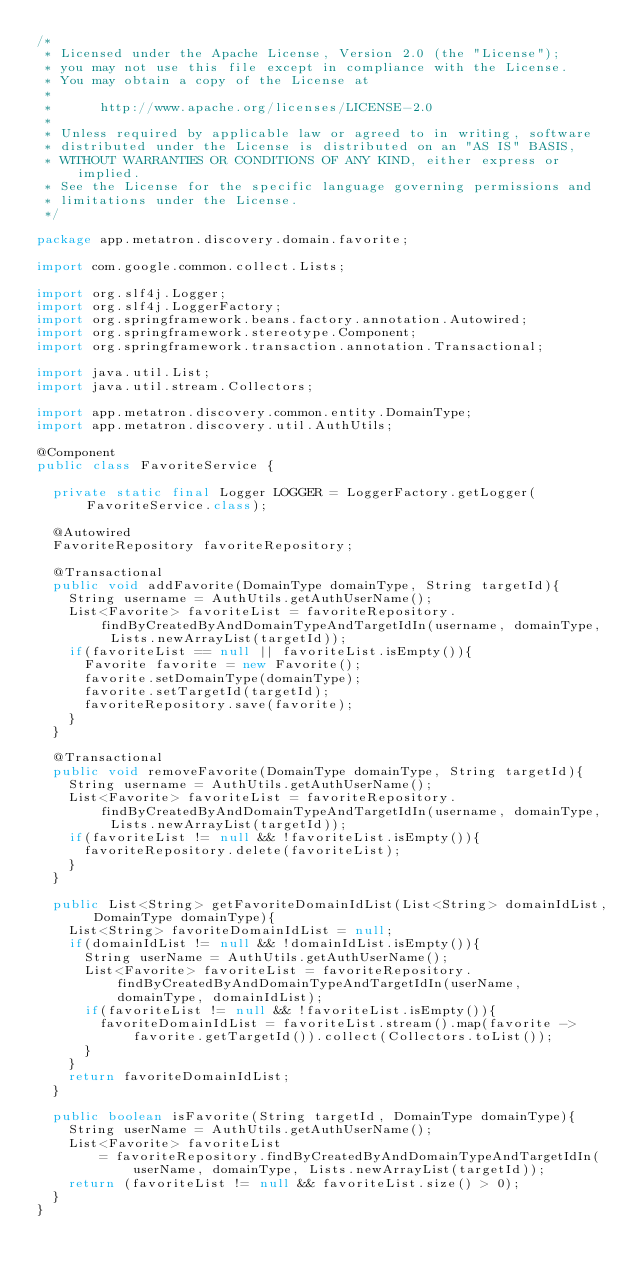<code> <loc_0><loc_0><loc_500><loc_500><_Java_>/*
 * Licensed under the Apache License, Version 2.0 (the "License");
 * you may not use this file except in compliance with the License.
 * You may obtain a copy of the License at
 *
 *      http://www.apache.org/licenses/LICENSE-2.0
 *
 * Unless required by applicable law or agreed to in writing, software
 * distributed under the License is distributed on an "AS IS" BASIS,
 * WITHOUT WARRANTIES OR CONDITIONS OF ANY KIND, either express or implied.
 * See the License for the specific language governing permissions and
 * limitations under the License.
 */

package app.metatron.discovery.domain.favorite;

import com.google.common.collect.Lists;

import org.slf4j.Logger;
import org.slf4j.LoggerFactory;
import org.springframework.beans.factory.annotation.Autowired;
import org.springframework.stereotype.Component;
import org.springframework.transaction.annotation.Transactional;

import java.util.List;
import java.util.stream.Collectors;

import app.metatron.discovery.common.entity.DomainType;
import app.metatron.discovery.util.AuthUtils;

@Component
public class FavoriteService {

  private static final Logger LOGGER = LoggerFactory.getLogger(FavoriteService.class);

  @Autowired
  FavoriteRepository favoriteRepository;

  @Transactional
  public void addFavorite(DomainType domainType, String targetId){
    String username = AuthUtils.getAuthUserName();
    List<Favorite> favoriteList = favoriteRepository.findByCreatedByAndDomainTypeAndTargetIdIn(username, domainType, Lists.newArrayList(targetId));
    if(favoriteList == null || favoriteList.isEmpty()){
      Favorite favorite = new Favorite();
      favorite.setDomainType(domainType);
      favorite.setTargetId(targetId);
      favoriteRepository.save(favorite);
    }
  }

  @Transactional
  public void removeFavorite(DomainType domainType, String targetId){
    String username = AuthUtils.getAuthUserName();
    List<Favorite> favoriteList = favoriteRepository.findByCreatedByAndDomainTypeAndTargetIdIn(username, domainType, Lists.newArrayList(targetId));
    if(favoriteList != null && !favoriteList.isEmpty()){
      favoriteRepository.delete(favoriteList);
    }
  }

  public List<String> getFavoriteDomainIdList(List<String> domainIdList, DomainType domainType){
    List<String> favoriteDomainIdList = null;
    if(domainIdList != null && !domainIdList.isEmpty()){
      String userName = AuthUtils.getAuthUserName();
      List<Favorite> favoriteList = favoriteRepository.findByCreatedByAndDomainTypeAndTargetIdIn(userName, domainType, domainIdList);
      if(favoriteList != null && !favoriteList.isEmpty()){
        favoriteDomainIdList = favoriteList.stream().map(favorite -> favorite.getTargetId()).collect(Collectors.toList());
      }
    }
    return favoriteDomainIdList;
  }

  public boolean isFavorite(String targetId, DomainType domainType){
    String userName = AuthUtils.getAuthUserName();
    List<Favorite> favoriteList
        = favoriteRepository.findByCreatedByAndDomainTypeAndTargetIdIn(userName, domainType, Lists.newArrayList(targetId));
    return (favoriteList != null && favoriteList.size() > 0);
  }
}
</code> 